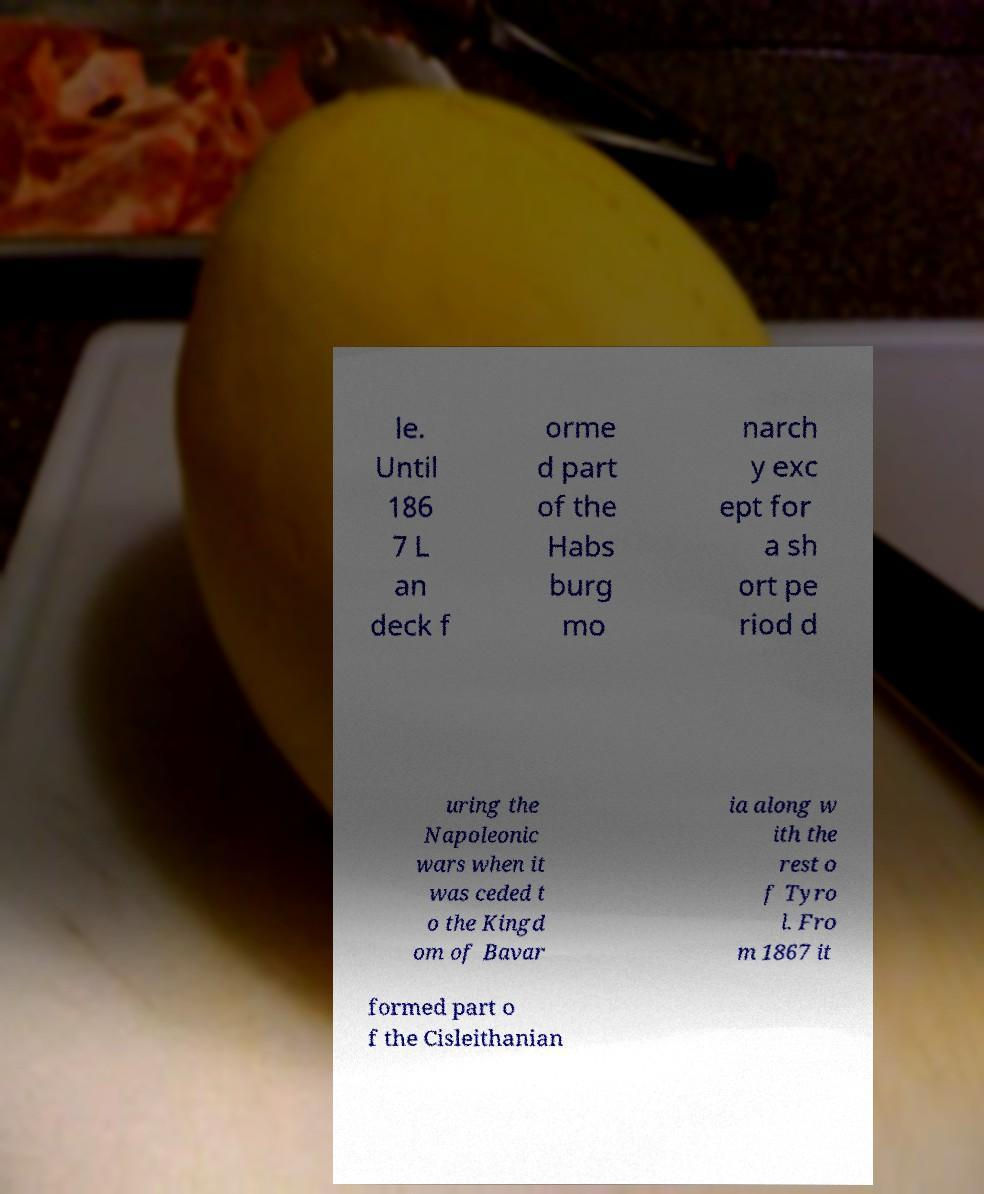I need the written content from this picture converted into text. Can you do that? le. Until 186 7 L an deck f orme d part of the Habs burg mo narch y exc ept for a sh ort pe riod d uring the Napoleonic wars when it was ceded t o the Kingd om of Bavar ia along w ith the rest o f Tyro l. Fro m 1867 it formed part o f the Cisleithanian 